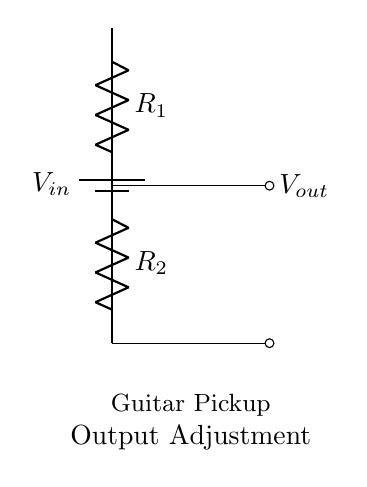What are the components in the circuit? The circuit includes a battery and two resistors. The battery provides input voltage, and the resistors are labeled R1 and R2.
Answer: battery, R1, R2 What does the output voltage depend on? The output voltage is determined by the values of the resistors R1 and R2 as per the voltage divider rule. The relationship indicates that the output voltage is a fraction of the input voltage based on the resistors’ values.
Answer: R1 and R2 values Where is the output voltage taken from? The output voltage is taken from the junction between the two resistors, R1 and R2, denoted as Vout in the circuit.
Answer: junction of R1 and R2 What is the purpose of the circuit? This circuit is used to adjust the output levels of guitar pickups by lowering the voltage level to match other components or outputs.
Answer: guitar pickup output adjustment If R1 is twice the value of R2, what happens to Vout? If R1 is twice the value of R2, the output voltage will be one-third of the input voltage due to the voltage divider relationship. Specifically, it provides a way to lower the signal without distorting it.
Answer: one-third of Vin How can you increase the output voltage? To increase the output voltage, you can decrease the value of resistor R2 or increase the value of resistor R1, which would affect the voltage divider ratio. The adjustment regulates the voltage levels for the output appropriately.
Answer: decrease R2 or increase R1 What is the significance of using a voltage divider for guitar circuits? Using a voltage divider allows for customizable control over pickup signals, enabling fine-tuning of output levels to prevent distortion and match with amplifiers. This flexibility is vital for achieving a desirable sound quality.
Answer: customizable output levels 